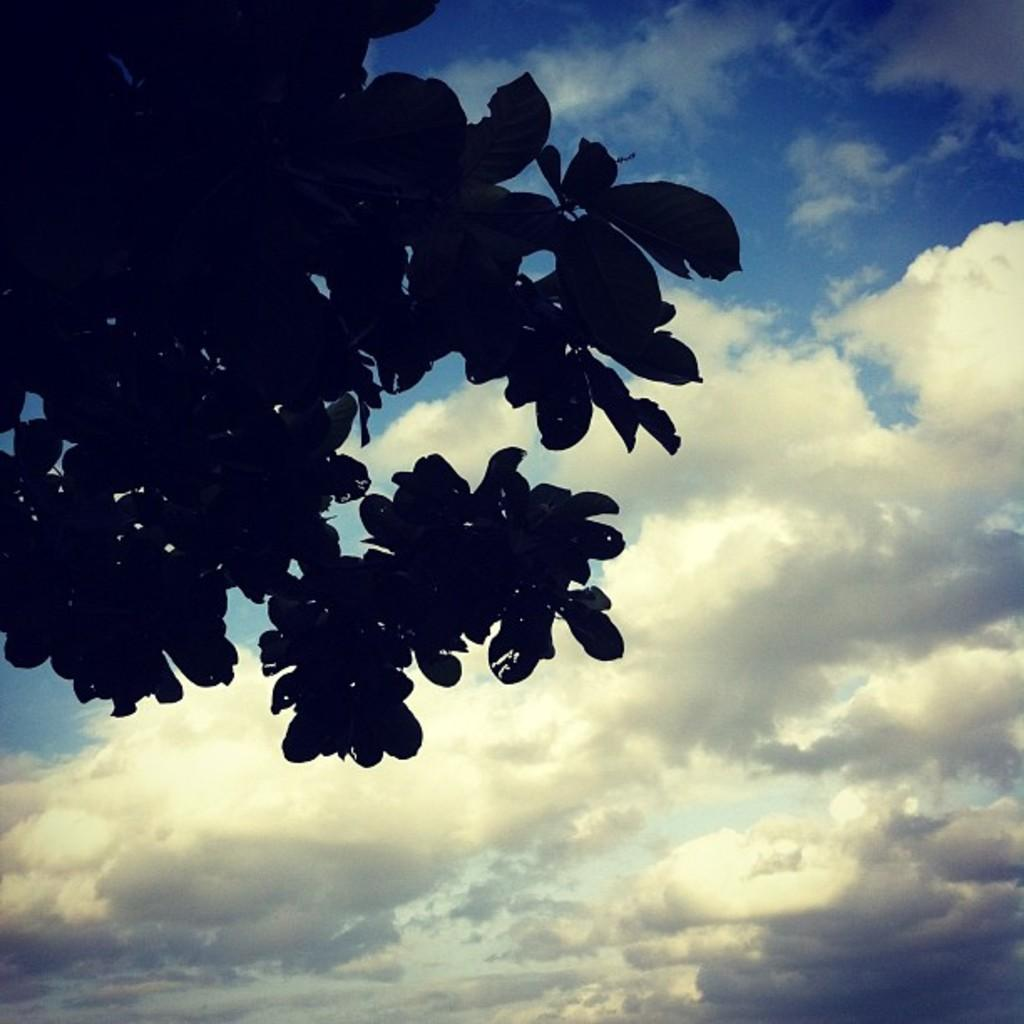What is the main subject in the foreground of the image? There are many leaves of a tree in the foreground of the image. What can be seen in the background of the image? The background of the image is the sky. What type of zinc is present in the image? There is no zinc present in the image; it features leaves of a tree in the foreground and the sky in the background. 